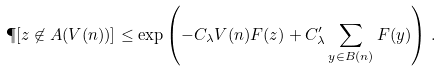Convert formula to latex. <formula><loc_0><loc_0><loc_500><loc_500>\P [ z \not \in A ( V ( n ) ) ] \leq \exp \left ( - C _ { \lambda } V ( n ) F ( z ) + C _ { \lambda } ^ { \prime } \sum _ { y \in B ( n ) } F ( y ) \right ) \, .</formula> 